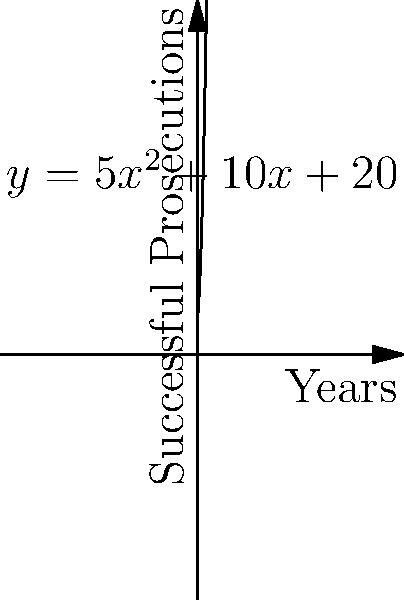The curve $y = 5x^2 + 10x + 20$ represents the number of successful prosecutions resulting from protected informant testimony over time, where $x$ is the number of years since implementing a new informant protection program. Calculate the total number of successful prosecutions over the first 5 years of the program. To find the total number of successful prosecutions over the first 5 years, we need to calculate the area under the curve from $x=0$ to $x=5$. This can be done using definite integration:

1) The integral of $y = 5x^2 + 10x + 20$ from 0 to 5 is:

   $$\int_0^5 (5x^2 + 10x + 20) dx$$

2) Integrate each term:
   $$\left[\frac{5x^3}{3} + 5x^2 + 20x\right]_0^5$$

3) Evaluate at the upper and lower bounds:
   $$\left(\frac{5(5^3)}{3} + 5(5^2) + 20(5)\right) - \left(\frac{5(0^3)}{3} + 5(0^2) + 20(0)\right)$$

4) Simplify:
   $$\left(\frac{625}{3} + 125 + 100\right) - 0$$

5) Calculate:
   $$\frac{625}{3} + 225 = \frac{1300}{3} \approx 433.33$$

The result represents the total number of successful prosecutions over the 5-year period.
Answer: $\frac{1300}{3}$ successful prosecutions 